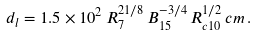Convert formula to latex. <formula><loc_0><loc_0><loc_500><loc_500>d _ { l } = 1 . 5 \times 1 0 ^ { 2 } \, R _ { 7 } ^ { 2 1 / 8 } \, B _ { 1 5 } ^ { - 3 / 4 } \, R _ { c 1 0 } ^ { 1 / 2 } \, c m \, .</formula> 